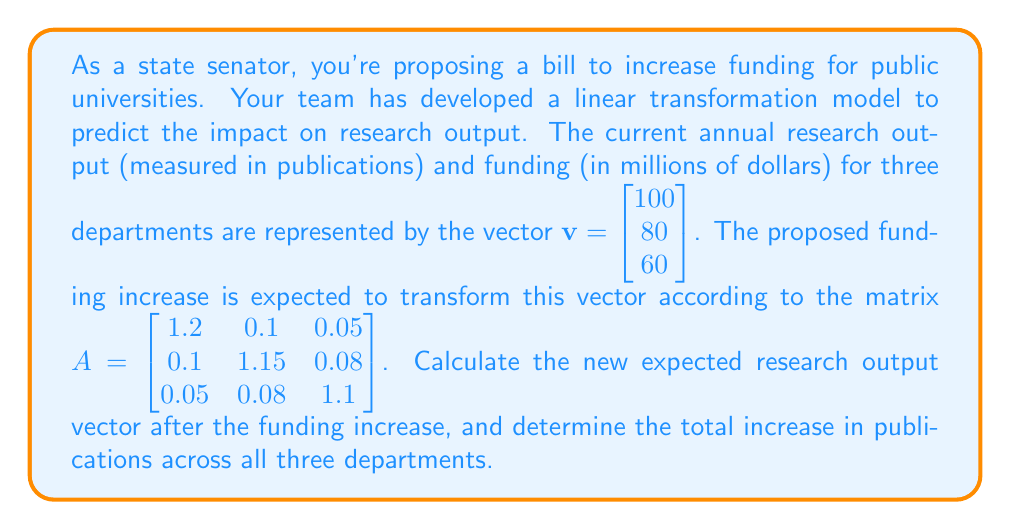Provide a solution to this math problem. To solve this problem, we need to apply the linear transformation represented by matrix $A$ to the initial vector $\mathbf{v}$. This is done through matrix multiplication.

1) First, let's multiply $A$ and $\mathbf{v}$:

   $A\mathbf{v} = \begin{bmatrix} 1.2 & 0.1 & 0.05 \\ 0.1 & 1.15 & 0.08 \\ 0.05 & 0.08 & 1.1 \end{bmatrix} \begin{bmatrix} 100 \\ 80 \\ 60 \end{bmatrix}$

2) Perform the matrix multiplication:

   $\begin{bmatrix}
   (1.2 \times 100) + (0.1 \times 80) + (0.05 \times 60) \\
   (0.1 \times 100) + (1.15 \times 80) + (0.08 \times 60) \\
   (0.05 \times 100) + (0.08 \times 80) + (1.1 \times 60)
   \end{bmatrix}$

3) Calculate each component:

   $\begin{bmatrix}
   120 + 8 + 3 \\
   10 + 92 + 4.8 \\
   5 + 6.4 + 66
   \end{bmatrix} = \begin{bmatrix}
   131 \\
   106.8 \\
   77.4
   \end{bmatrix}$

4) To find the total increase, we need to sum the differences between the new and original vectors:

   $\begin{bmatrix}
   131 - 100 \\
   106.8 - 80 \\
   77.4 - 60
   \end{bmatrix} = \begin{bmatrix}
   31 \\
   26.8 \\
   17.4
   \end{bmatrix}$

5) Sum these differences:

   $31 + 26.8 + 17.4 = 75.2$

Therefore, the new expected research output vector is $\begin{bmatrix} 131 \\ 106.8 \\ 77.4 \end{bmatrix}$, and the total increase in publications across all three departments is 75.2.
Answer: The new expected research output vector is $\begin{bmatrix} 131 \\ 106.8 \\ 77.4 \end{bmatrix}$, and the total increase in publications across all three departments is 75.2. 